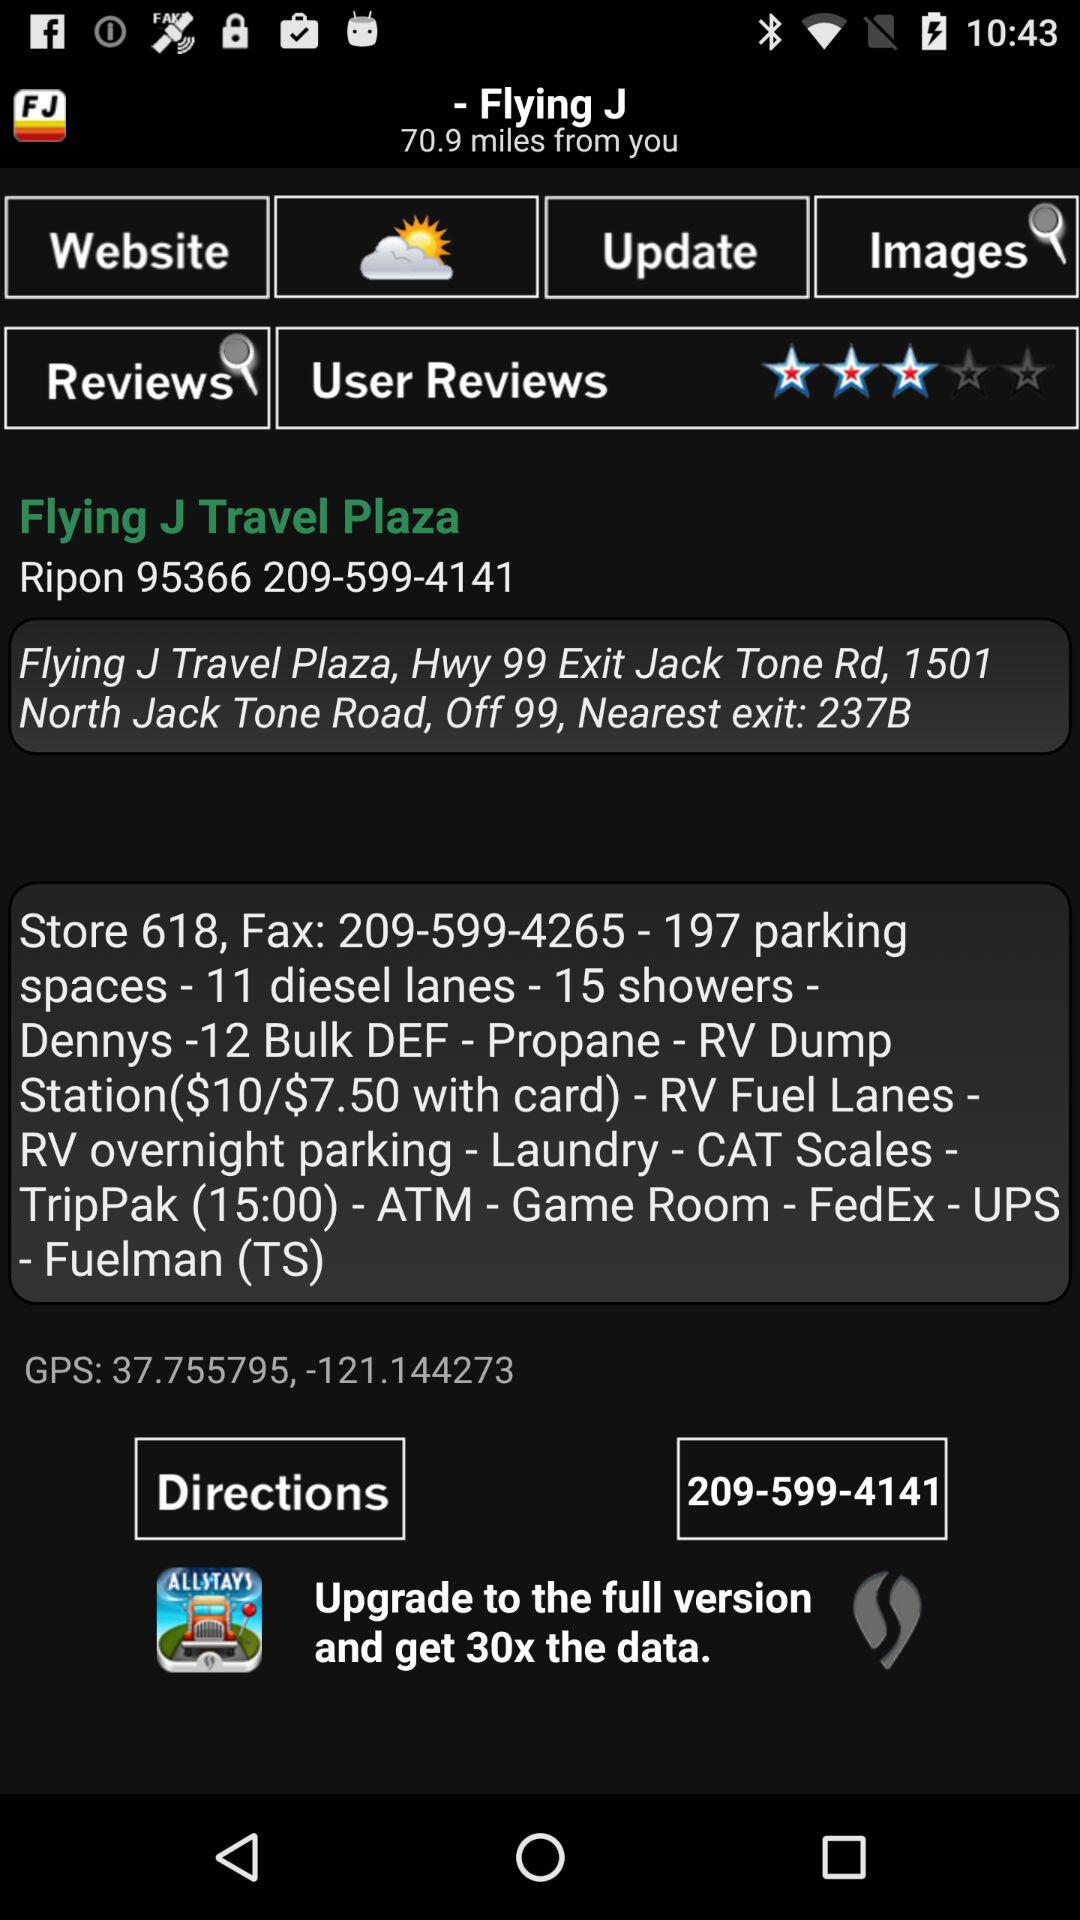What is the nearest exit? The nearest exit is 237B. 